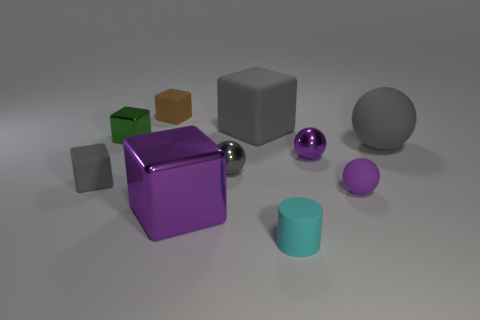Subtract all big gray rubber blocks. How many blocks are left? 4 Subtract 2 balls. How many balls are left? 2 Subtract all purple blocks. How many blocks are left? 4 Subtract all yellow spheres. Subtract all brown blocks. How many spheres are left? 4 Subtract all balls. How many objects are left? 6 Add 9 brown matte things. How many brown matte things are left? 10 Add 2 large rubber objects. How many large rubber objects exist? 4 Subtract 1 brown cubes. How many objects are left? 9 Subtract all small blocks. Subtract all brown cubes. How many objects are left? 6 